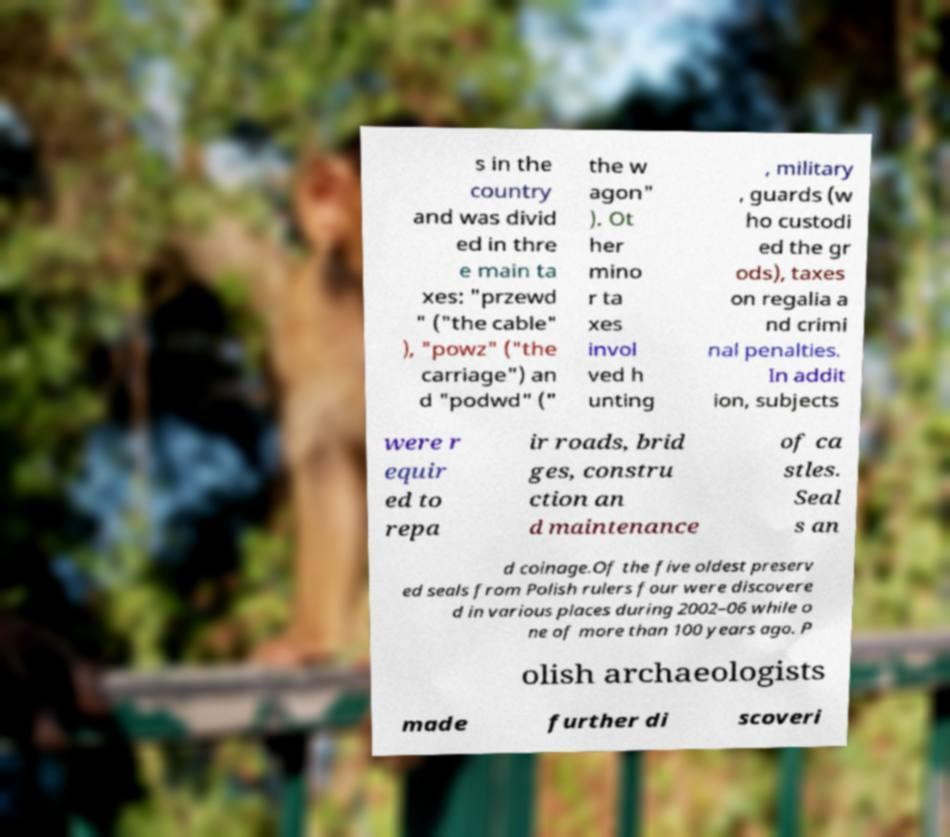Please read and relay the text visible in this image. What does it say? s in the country and was divid ed in thre e main ta xes: "przewd " ("the cable" ), "powz" ("the carriage") an d "podwd" (" the w agon" ). Ot her mino r ta xes invol ved h unting , military , guards (w ho custodi ed the gr ods), taxes on regalia a nd crimi nal penalties. In addit ion, subjects were r equir ed to repa ir roads, brid ges, constru ction an d maintenance of ca stles. Seal s an d coinage.Of the five oldest preserv ed seals from Polish rulers four were discovere d in various places during 2002–06 while o ne of more than 100 years ago. P olish archaeologists made further di scoveri 